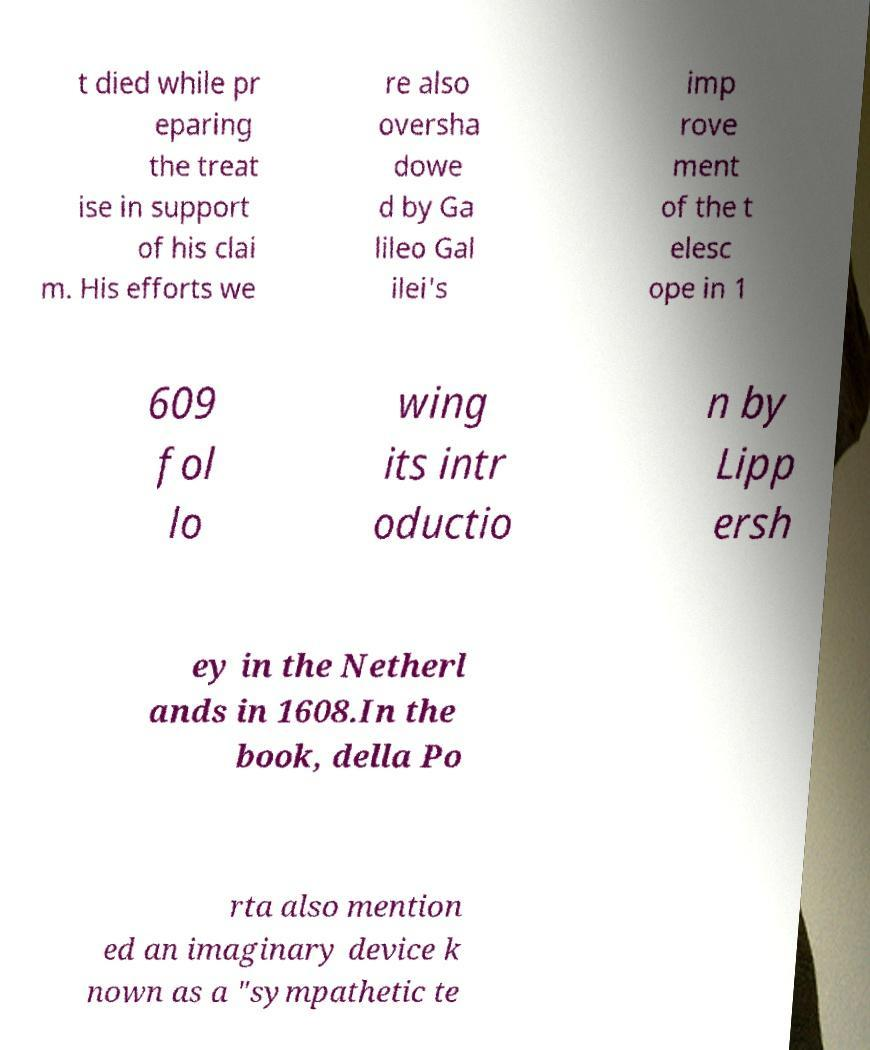Can you accurately transcribe the text from the provided image for me? t died while pr eparing the treat ise in support of his clai m. His efforts we re also oversha dowe d by Ga lileo Gal ilei's imp rove ment of the t elesc ope in 1 609 fol lo wing its intr oductio n by Lipp ersh ey in the Netherl ands in 1608.In the book, della Po rta also mention ed an imaginary device k nown as a "sympathetic te 